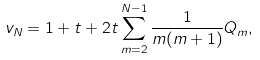<formula> <loc_0><loc_0><loc_500><loc_500>v _ { N } = 1 + t + 2 t \sum _ { m = 2 } ^ { N - 1 } \frac { 1 } { m ( m + 1 ) } Q _ { m } ,</formula> 